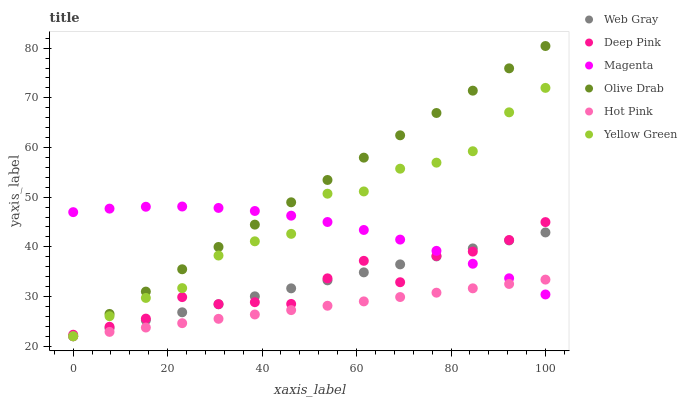Does Hot Pink have the minimum area under the curve?
Answer yes or no. Yes. Does Olive Drab have the maximum area under the curve?
Answer yes or no. Yes. Does Yellow Green have the minimum area under the curve?
Answer yes or no. No. Does Yellow Green have the maximum area under the curve?
Answer yes or no. No. Is Web Gray the smoothest?
Answer yes or no. Yes. Is Yellow Green the roughest?
Answer yes or no. Yes. Is Hot Pink the smoothest?
Answer yes or no. No. Is Hot Pink the roughest?
Answer yes or no. No. Does Web Gray have the lowest value?
Answer yes or no. Yes. Does Deep Pink have the lowest value?
Answer yes or no. No. Does Olive Drab have the highest value?
Answer yes or no. Yes. Does Yellow Green have the highest value?
Answer yes or no. No. Is Hot Pink less than Deep Pink?
Answer yes or no. Yes. Is Deep Pink greater than Hot Pink?
Answer yes or no. Yes. Does Magenta intersect Yellow Green?
Answer yes or no. Yes. Is Magenta less than Yellow Green?
Answer yes or no. No. Is Magenta greater than Yellow Green?
Answer yes or no. No. Does Hot Pink intersect Deep Pink?
Answer yes or no. No. 